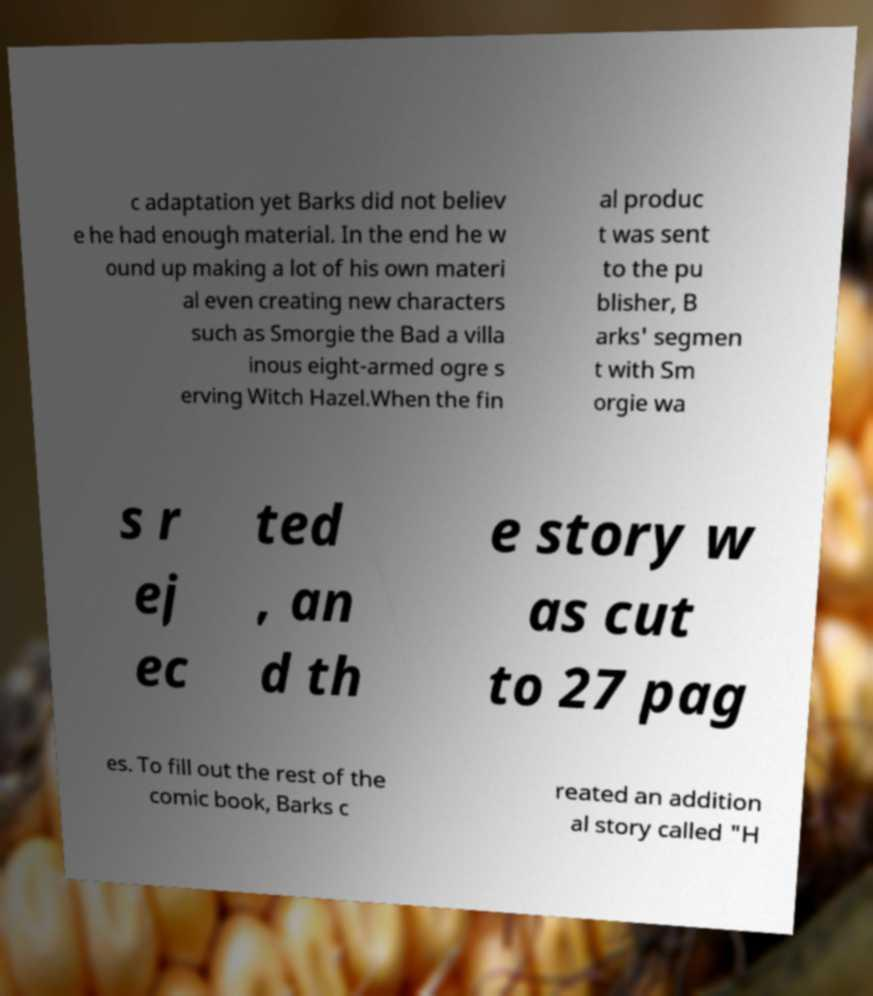There's text embedded in this image that I need extracted. Can you transcribe it verbatim? c adaptation yet Barks did not believ e he had enough material. In the end he w ound up making a lot of his own materi al even creating new characters such as Smorgie the Bad a villa inous eight-armed ogre s erving Witch Hazel.When the fin al produc t was sent to the pu blisher, B arks' segmen t with Sm orgie wa s r ej ec ted , an d th e story w as cut to 27 pag es. To fill out the rest of the comic book, Barks c reated an addition al story called "H 